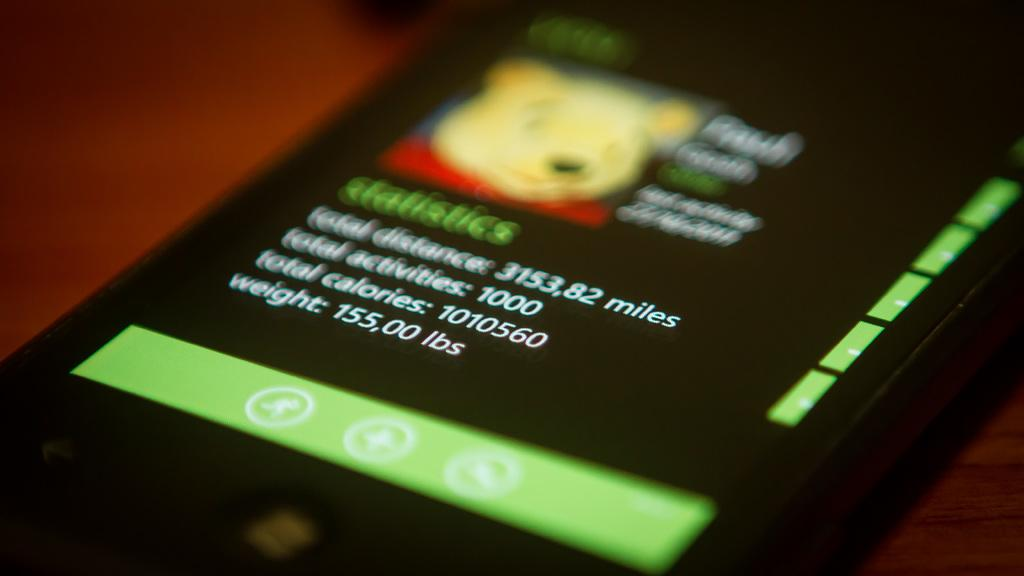<image>
Summarize the visual content of the image. a screen displaying wight of 155,00 lbs on the bottom line 